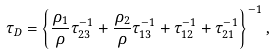Convert formula to latex. <formula><loc_0><loc_0><loc_500><loc_500>\tau _ { D } = \left \{ \frac { \rho _ { 1 } } { \rho } \tau _ { 2 3 } ^ { - 1 } + \frac { \rho _ { 2 } } { \rho } \tau _ { 1 3 } ^ { - 1 } + \tau _ { 1 2 } ^ { - 1 } + \tau _ { 2 1 } ^ { - 1 } \right \} ^ { - 1 } ,</formula> 